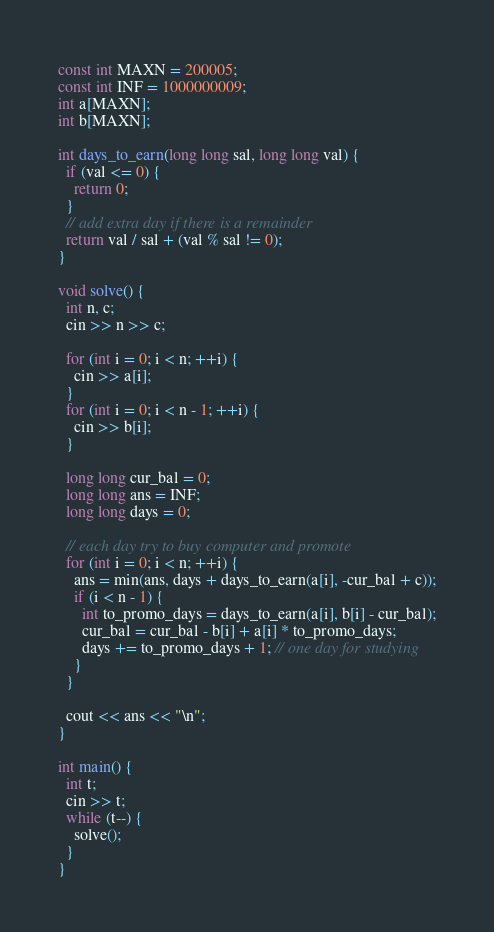Convert code to text. <code><loc_0><loc_0><loc_500><loc_500><_C++_>
const int MAXN = 200005;
const int INF = 1000000009;
int a[MAXN];
int b[MAXN];

int days_to_earn(long long sal, long long val) {
  if (val <= 0) {
    return 0;
  }
  // add extra day if there is a remainder
  return val / sal + (val % sal != 0);
}

void solve() {
  int n, c;
  cin >> n >> c;

  for (int i = 0; i < n; ++i) {
    cin >> a[i];
  }
  for (int i = 0; i < n - 1; ++i) {
    cin >> b[i];
  }

  long long cur_bal = 0;
  long long ans = INF;
  long long days = 0;

  // each day try to buy computer and promote
  for (int i = 0; i < n; ++i) {
    ans = min(ans, days + days_to_earn(a[i], -cur_bal + c));
    if (i < n - 1) {
      int to_promo_days = days_to_earn(a[i], b[i] - cur_bal);
      cur_bal = cur_bal - b[i] + a[i] * to_promo_days;
      days += to_promo_days + 1; // one day for studying
    }
  }

  cout << ans << "\n";
}

int main() {
  int t;
  cin >> t;
  while (t--) {
    solve();
  }
}
</code> 